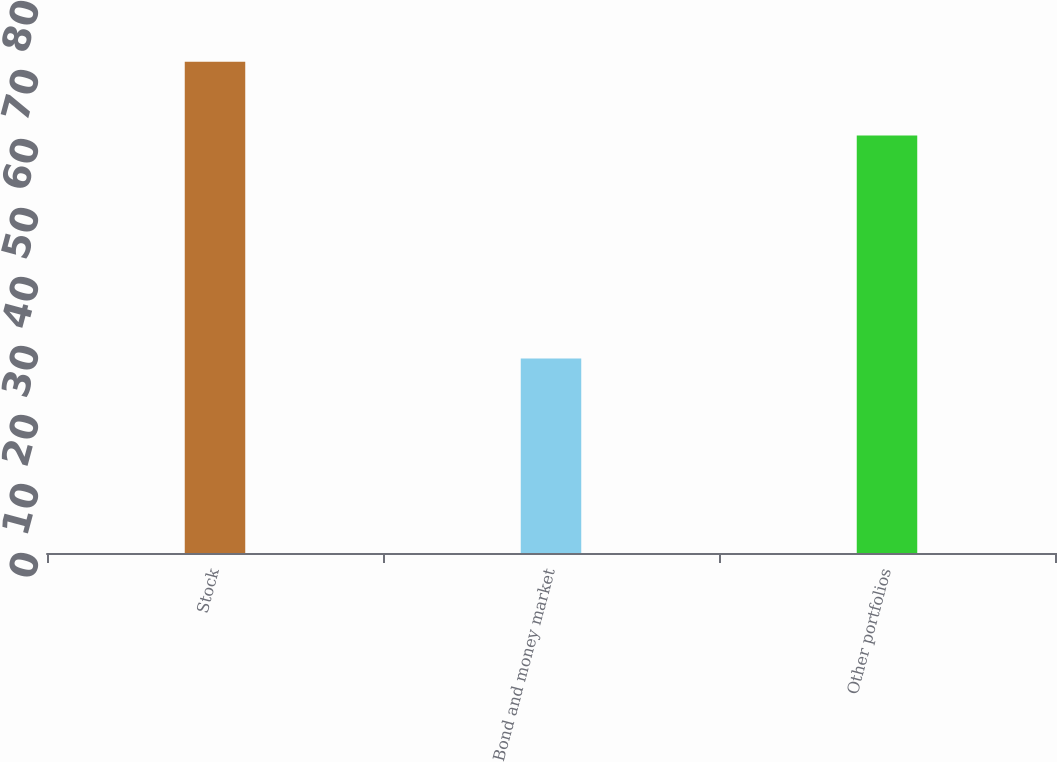Convert chart. <chart><loc_0><loc_0><loc_500><loc_500><bar_chart><fcel>Stock<fcel>Bond and money market<fcel>Other portfolios<nl><fcel>71.2<fcel>28.2<fcel>60.5<nl></chart> 